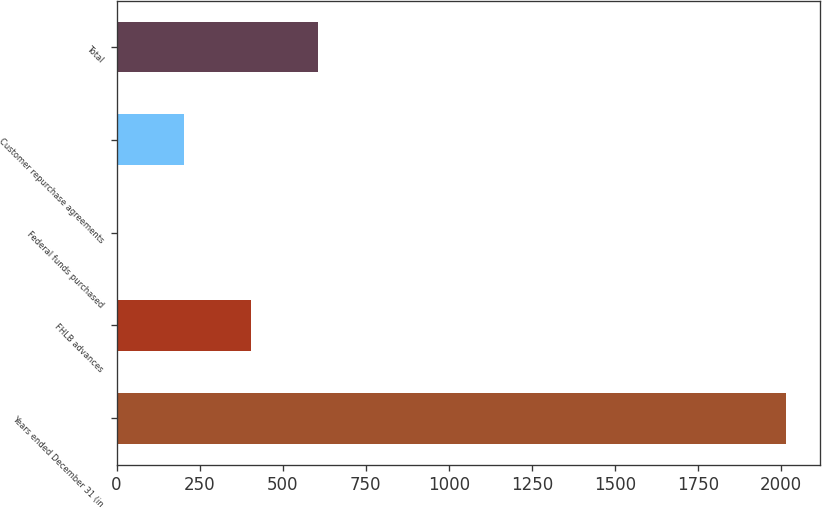<chart> <loc_0><loc_0><loc_500><loc_500><bar_chart><fcel>Years ended December 31 (in<fcel>FHLB advances<fcel>Federal funds purchased<fcel>Customer repurchase agreements<fcel>Total<nl><fcel>2015<fcel>403.64<fcel>0.8<fcel>202.22<fcel>605.06<nl></chart> 